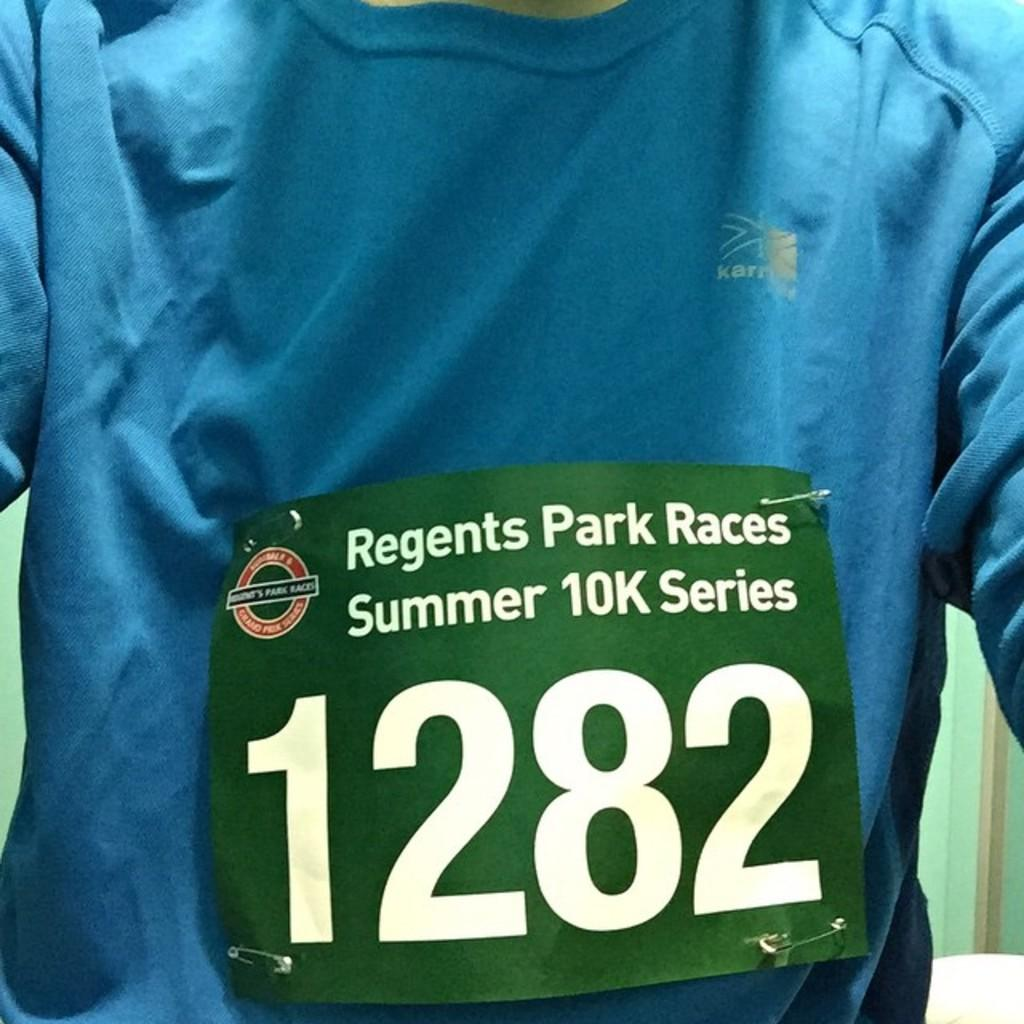<image>
Share a concise interpretation of the image provided. A person in a blue shirt is wearing a sticker that says Regents Park Races Summer 10K Series 1282. 